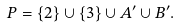<formula> <loc_0><loc_0><loc_500><loc_500>P = \left \{ 2 \right \} \cup \left \{ 3 \right \} \cup A ^ { \prime } \cup B ^ { \prime } .</formula> 